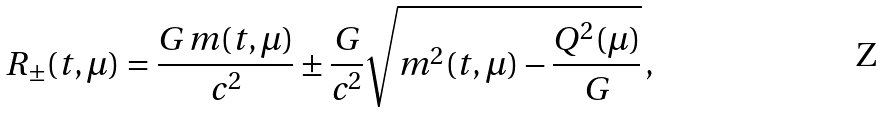Convert formula to latex. <formula><loc_0><loc_0><loc_500><loc_500>R _ { \pm } ( t , \mu ) = \frac { G \, m ( t , \mu ) } { c ^ { 2 } } \pm \frac { G } { c ^ { 2 } } \sqrt { m ^ { 2 } ( t , \mu ) - \frac { Q ^ { 2 } ( \mu ) } { G } } \, ,</formula> 